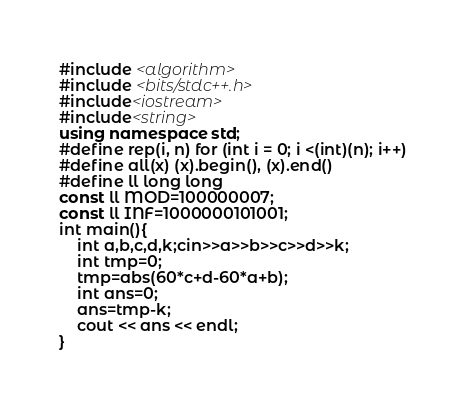<code> <loc_0><loc_0><loc_500><loc_500><_C++_>#include <algorithm>
#include <bits/stdc++.h>
#include<iostream>
#include<string>
using namespace std;
#define rep(i, n) for (int i = 0; i <(int)(n); i++)
#define all(x) (x).begin(), (x).end()
#define ll long long
const ll MOD=100000007;
const ll INF=1000000101001;
int main(){
    int a,b,c,d,k;cin>>a>>b>>c>>d>>k;
    int tmp=0;
    tmp=abs(60*c+d-60*a+b);
    int ans=0;
    ans=tmp-k;
    cout << ans << endl;
}</code> 